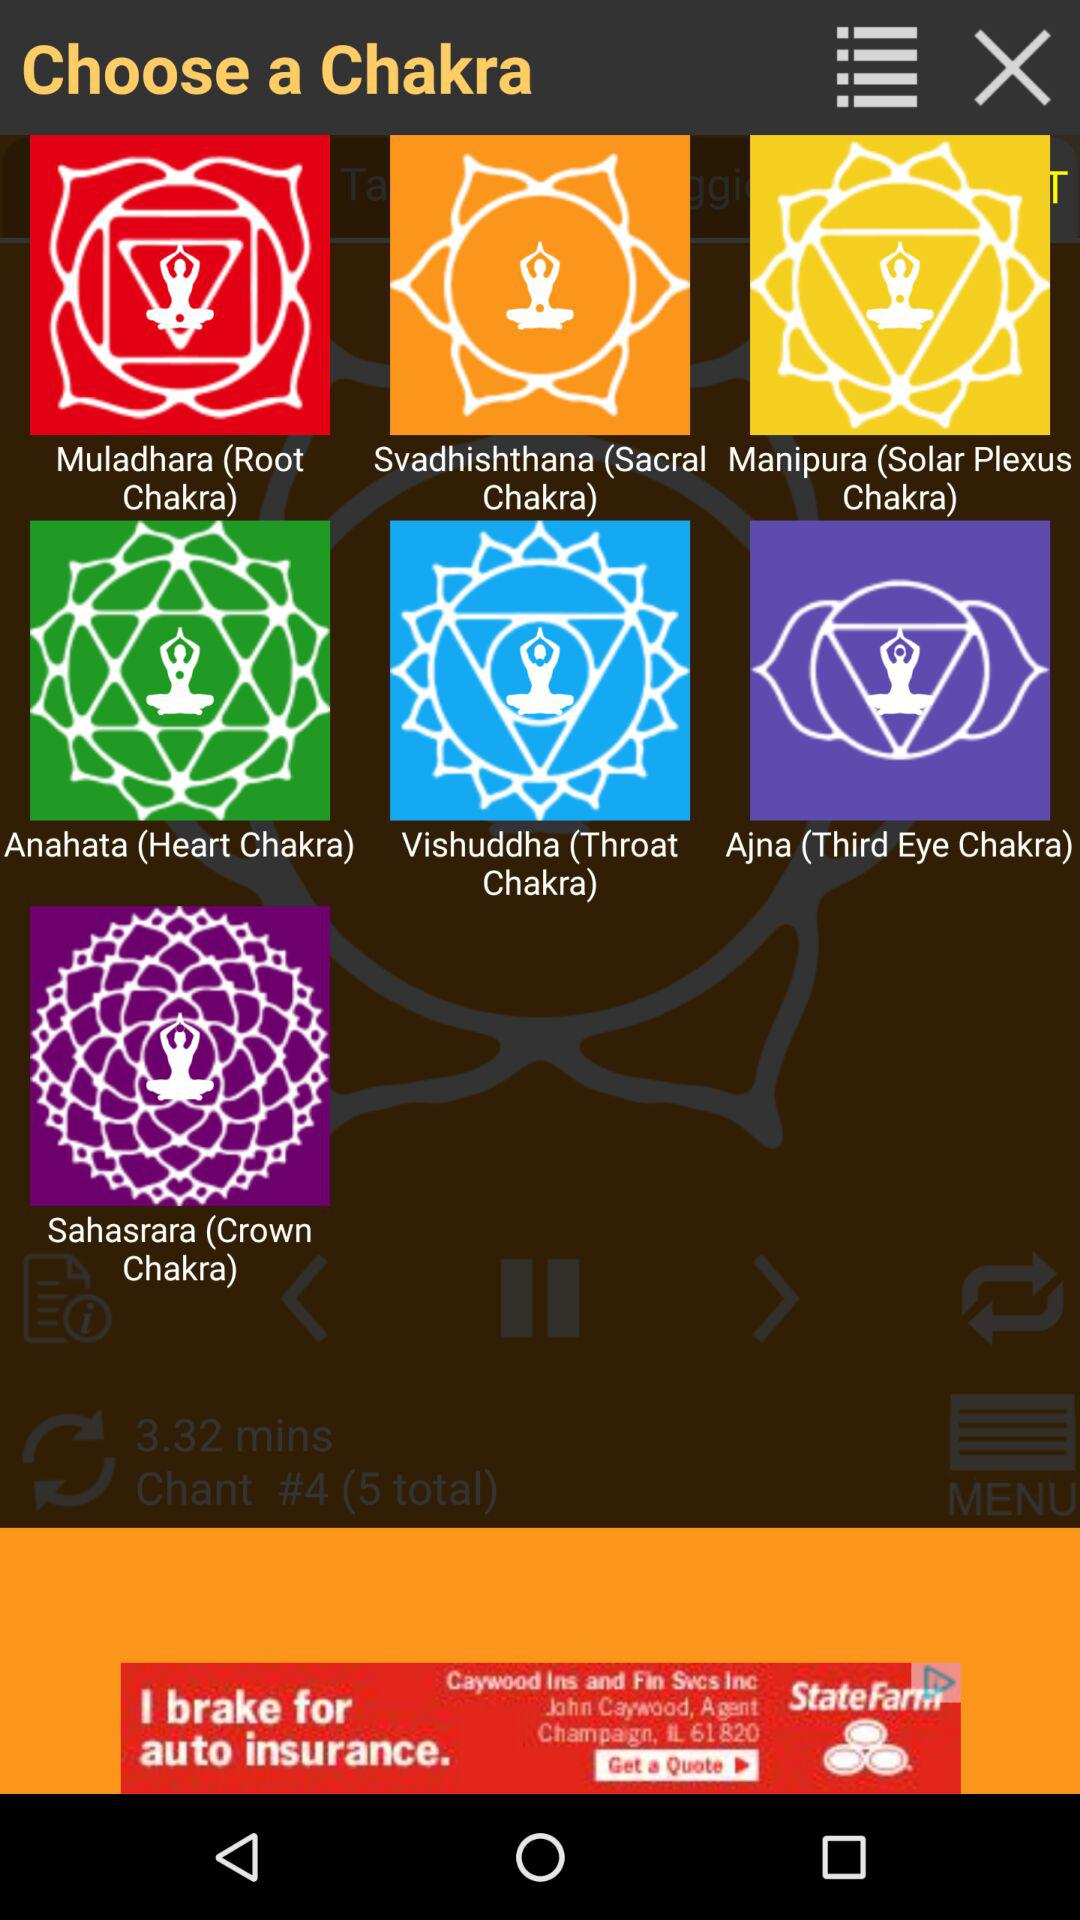What are the different available chakras? The different available chakras are "Muladhara (Root Chakra)", "Svadhishthana (Sacral Chakra)", "Manipura (Solar Plexus Chakra)", "Anahata (Heart Chakra)", "Vishuddha (Throat Chakra)", "Ajna (Third Eye Chakra)" and "Sahasrara (Crown Chakra)". 